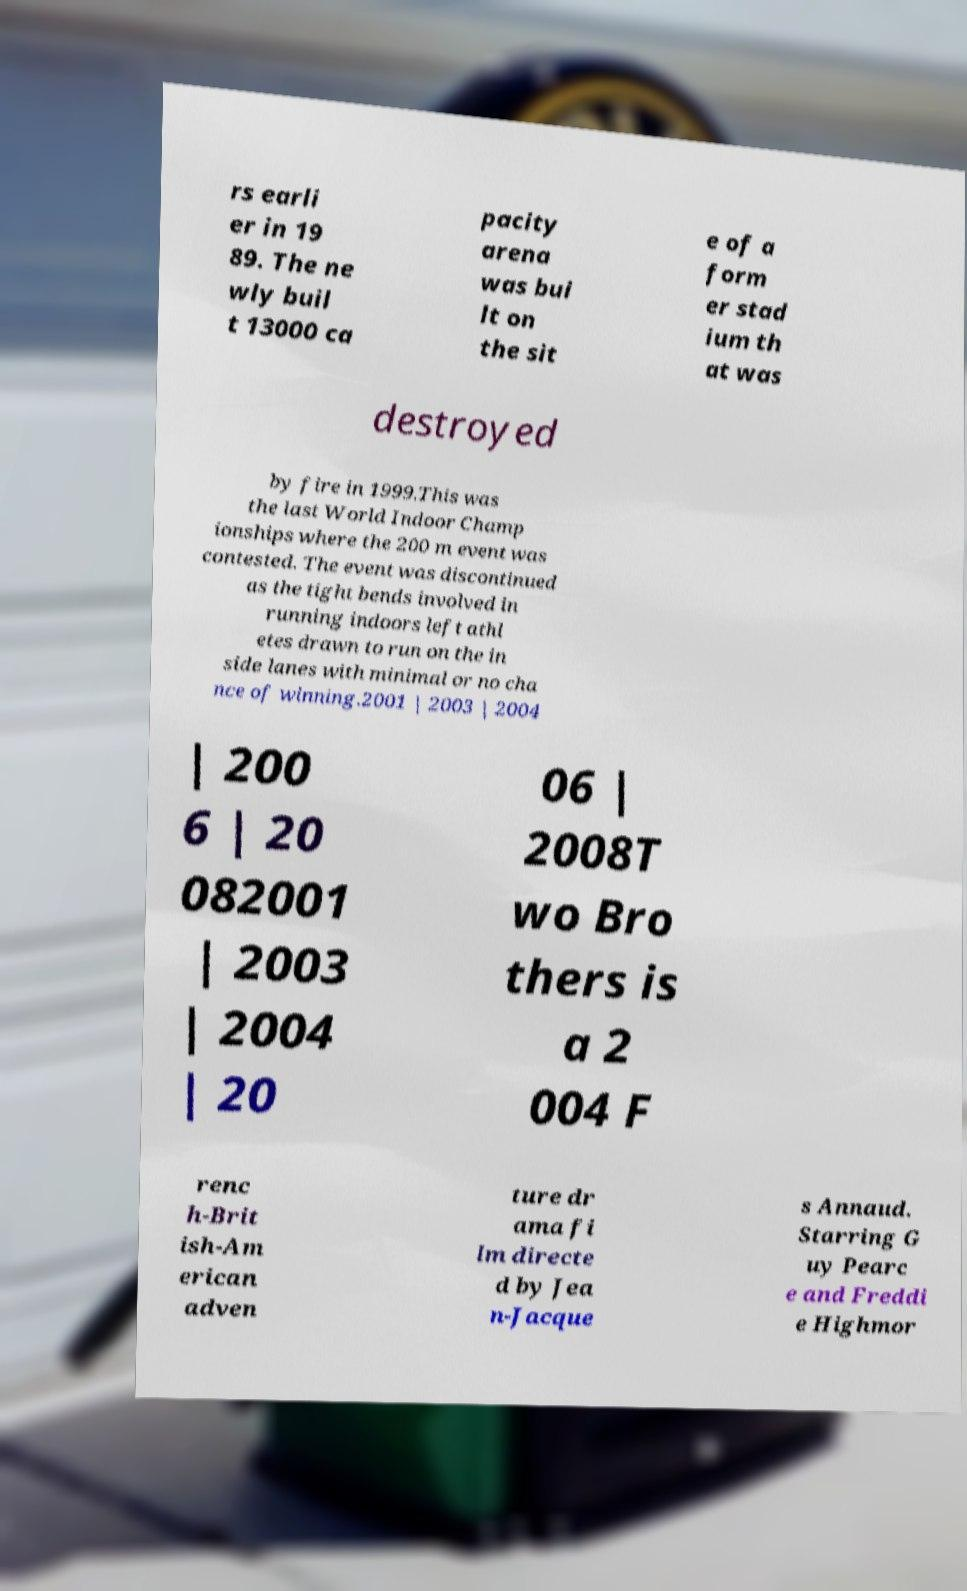I need the written content from this picture converted into text. Can you do that? rs earli er in 19 89. The ne wly buil t 13000 ca pacity arena was bui lt on the sit e of a form er stad ium th at was destroyed by fire in 1999.This was the last World Indoor Champ ionships where the 200 m event was contested. The event was discontinued as the tight bends involved in running indoors left athl etes drawn to run on the in side lanes with minimal or no cha nce of winning.2001 | 2003 | 2004 | 200 6 | 20 082001 | 2003 | 2004 | 20 06 | 2008T wo Bro thers is a 2 004 F renc h-Brit ish-Am erican adven ture dr ama fi lm directe d by Jea n-Jacque s Annaud. Starring G uy Pearc e and Freddi e Highmor 